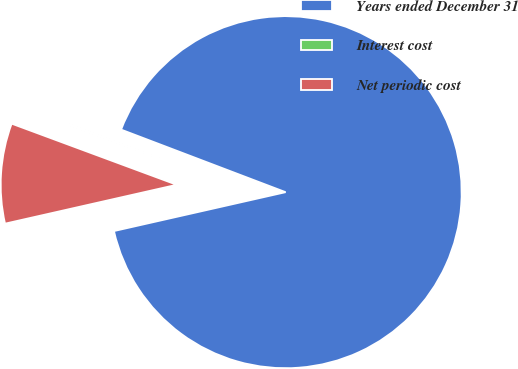Convert chart. <chart><loc_0><loc_0><loc_500><loc_500><pie_chart><fcel>Years ended December 31<fcel>Interest cost<fcel>Net periodic cost<nl><fcel>90.67%<fcel>0.14%<fcel>9.19%<nl></chart> 